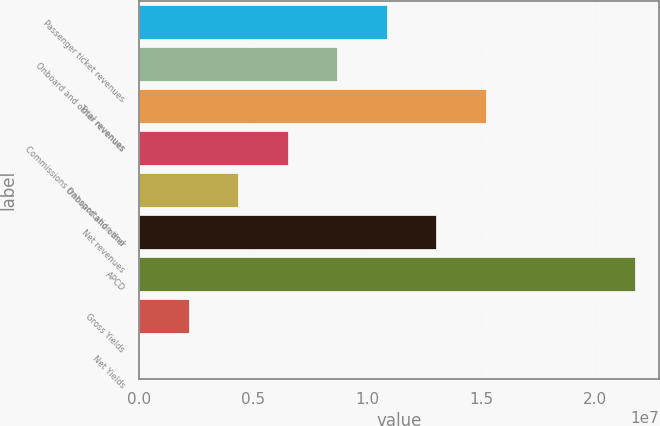Convert chart to OTSL. <chart><loc_0><loc_0><loc_500><loc_500><bar_chart><fcel>Passenger ticket revenues<fcel>Onboard and other revenues<fcel>Total revenues<fcel>Commissions transportation and<fcel>Onboard and other<fcel>Net revenues<fcel>APCD<fcel>Gross Yields<fcel>Net Yields<nl><fcel>1.08669e+07<fcel>8.69359e+06<fcel>1.52137e+07<fcel>6.52024e+06<fcel>4.34688e+06<fcel>1.30403e+07<fcel>2.17337e+07<fcel>2.17353e+06<fcel>171.9<nl></chart> 